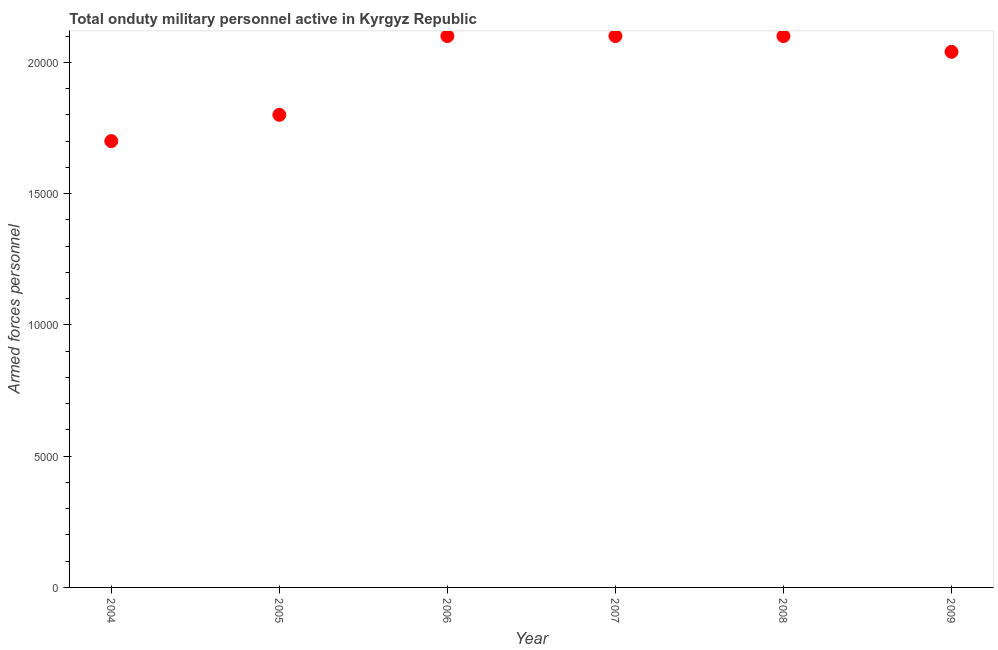What is the number of armed forces personnel in 2005?
Provide a succinct answer. 1.80e+04. Across all years, what is the maximum number of armed forces personnel?
Make the answer very short. 2.10e+04. Across all years, what is the minimum number of armed forces personnel?
Provide a short and direct response. 1.70e+04. In which year was the number of armed forces personnel maximum?
Ensure brevity in your answer.  2006. What is the sum of the number of armed forces personnel?
Your answer should be compact. 1.18e+05. What is the difference between the number of armed forces personnel in 2005 and 2006?
Your response must be concise. -3000. What is the average number of armed forces personnel per year?
Your response must be concise. 1.97e+04. What is the median number of armed forces personnel?
Offer a terse response. 2.07e+04. In how many years, is the number of armed forces personnel greater than 7000 ?
Provide a short and direct response. 6. Do a majority of the years between 2005 and 2008 (inclusive) have number of armed forces personnel greater than 1000 ?
Your answer should be very brief. Yes. What is the ratio of the number of armed forces personnel in 2005 to that in 2006?
Provide a succinct answer. 0.86. Is the number of armed forces personnel in 2006 less than that in 2008?
Make the answer very short. No. Is the sum of the number of armed forces personnel in 2006 and 2009 greater than the maximum number of armed forces personnel across all years?
Provide a succinct answer. Yes. What is the difference between the highest and the lowest number of armed forces personnel?
Provide a short and direct response. 4000. In how many years, is the number of armed forces personnel greater than the average number of armed forces personnel taken over all years?
Give a very brief answer. 4. How many dotlines are there?
Offer a very short reply. 1. What is the difference between two consecutive major ticks on the Y-axis?
Your answer should be compact. 5000. Does the graph contain any zero values?
Your answer should be compact. No. What is the title of the graph?
Provide a succinct answer. Total onduty military personnel active in Kyrgyz Republic. What is the label or title of the Y-axis?
Offer a very short reply. Armed forces personnel. What is the Armed forces personnel in 2004?
Your answer should be very brief. 1.70e+04. What is the Armed forces personnel in 2005?
Give a very brief answer. 1.80e+04. What is the Armed forces personnel in 2006?
Ensure brevity in your answer.  2.10e+04. What is the Armed forces personnel in 2007?
Provide a succinct answer. 2.10e+04. What is the Armed forces personnel in 2008?
Ensure brevity in your answer.  2.10e+04. What is the Armed forces personnel in 2009?
Offer a very short reply. 2.04e+04. What is the difference between the Armed forces personnel in 2004 and 2005?
Your answer should be very brief. -1000. What is the difference between the Armed forces personnel in 2004 and 2006?
Your answer should be very brief. -4000. What is the difference between the Armed forces personnel in 2004 and 2007?
Keep it short and to the point. -4000. What is the difference between the Armed forces personnel in 2004 and 2008?
Ensure brevity in your answer.  -4000. What is the difference between the Armed forces personnel in 2004 and 2009?
Make the answer very short. -3400. What is the difference between the Armed forces personnel in 2005 and 2006?
Give a very brief answer. -3000. What is the difference between the Armed forces personnel in 2005 and 2007?
Ensure brevity in your answer.  -3000. What is the difference between the Armed forces personnel in 2005 and 2008?
Provide a short and direct response. -3000. What is the difference between the Armed forces personnel in 2005 and 2009?
Give a very brief answer. -2400. What is the difference between the Armed forces personnel in 2006 and 2009?
Make the answer very short. 600. What is the difference between the Armed forces personnel in 2007 and 2008?
Your answer should be compact. 0. What is the difference between the Armed forces personnel in 2007 and 2009?
Your answer should be very brief. 600. What is the difference between the Armed forces personnel in 2008 and 2009?
Provide a short and direct response. 600. What is the ratio of the Armed forces personnel in 2004 to that in 2005?
Offer a terse response. 0.94. What is the ratio of the Armed forces personnel in 2004 to that in 2006?
Give a very brief answer. 0.81. What is the ratio of the Armed forces personnel in 2004 to that in 2007?
Make the answer very short. 0.81. What is the ratio of the Armed forces personnel in 2004 to that in 2008?
Your response must be concise. 0.81. What is the ratio of the Armed forces personnel in 2004 to that in 2009?
Ensure brevity in your answer.  0.83. What is the ratio of the Armed forces personnel in 2005 to that in 2006?
Offer a very short reply. 0.86. What is the ratio of the Armed forces personnel in 2005 to that in 2007?
Offer a very short reply. 0.86. What is the ratio of the Armed forces personnel in 2005 to that in 2008?
Provide a succinct answer. 0.86. What is the ratio of the Armed forces personnel in 2005 to that in 2009?
Offer a terse response. 0.88. What is the ratio of the Armed forces personnel in 2006 to that in 2009?
Ensure brevity in your answer.  1.03. What is the ratio of the Armed forces personnel in 2007 to that in 2008?
Your answer should be very brief. 1. 